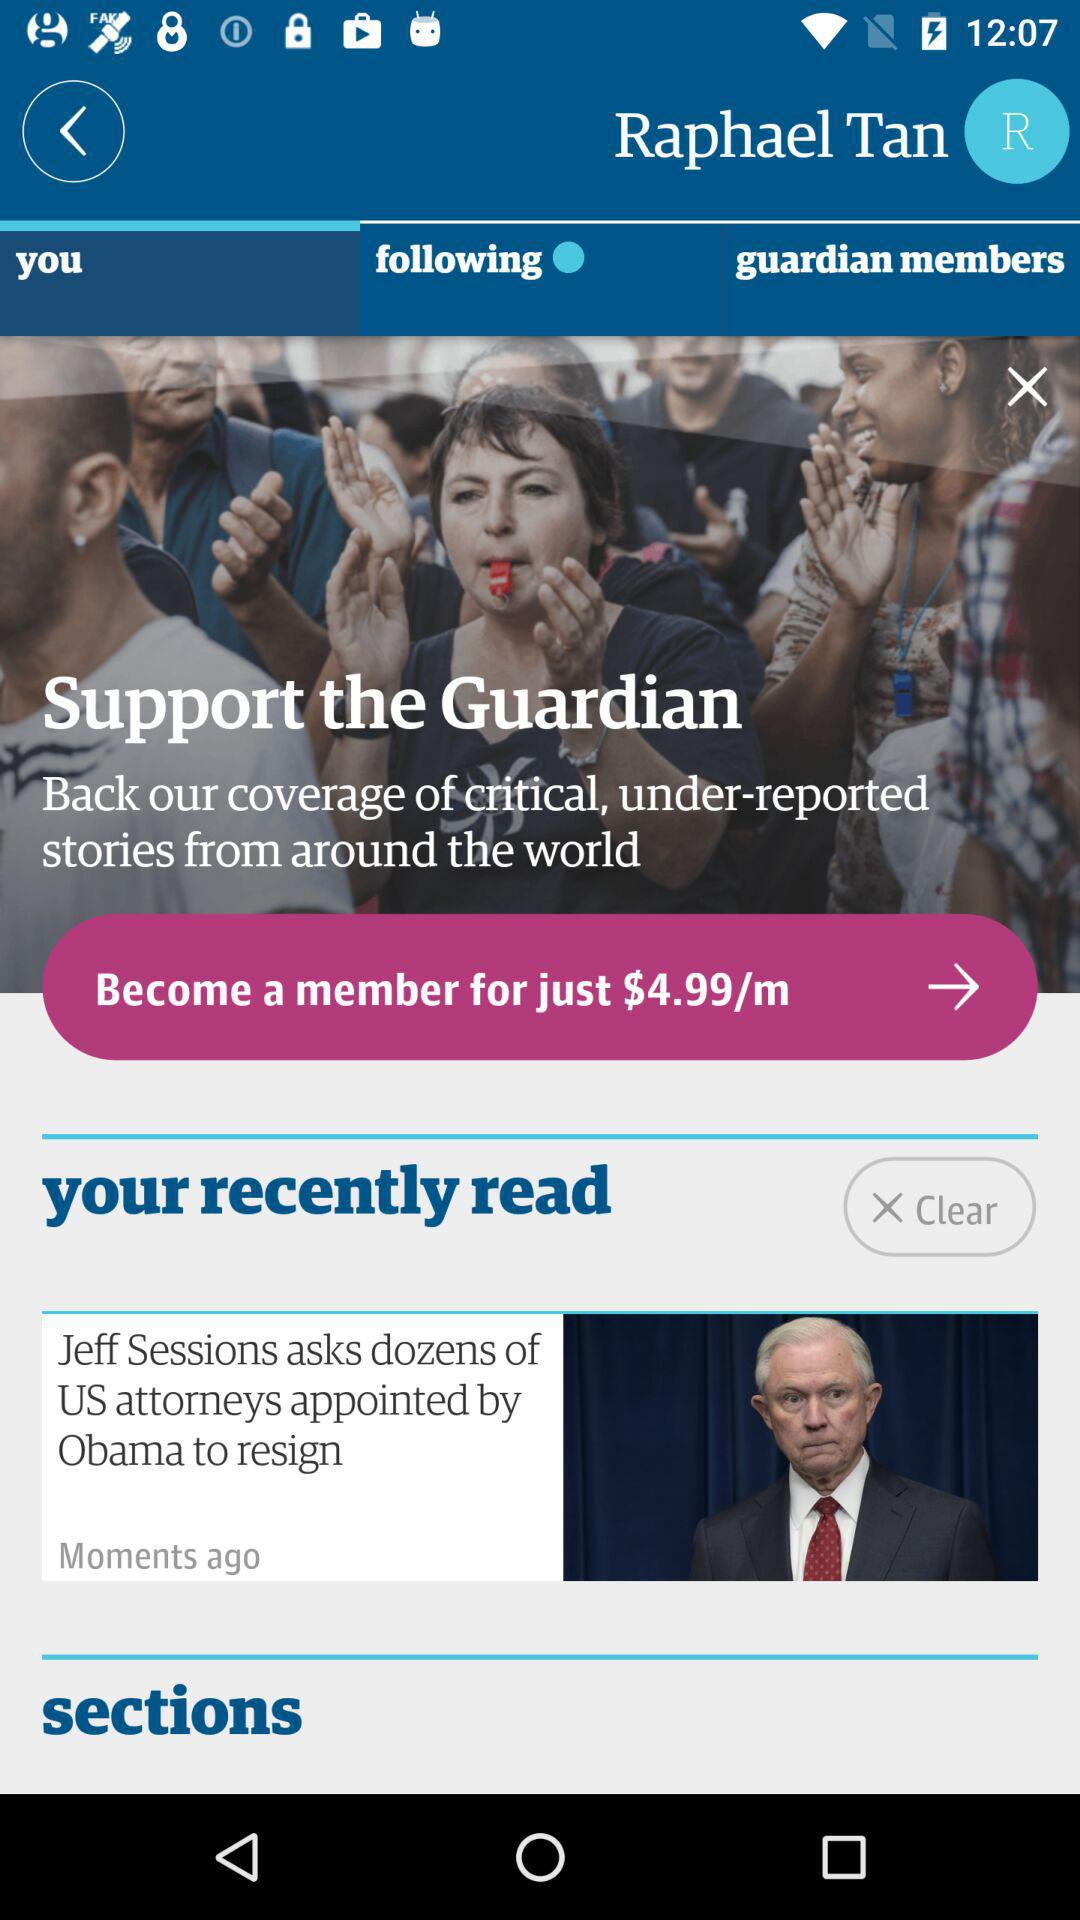What is the name of the author? The name of the author is "Raphael Tan". 